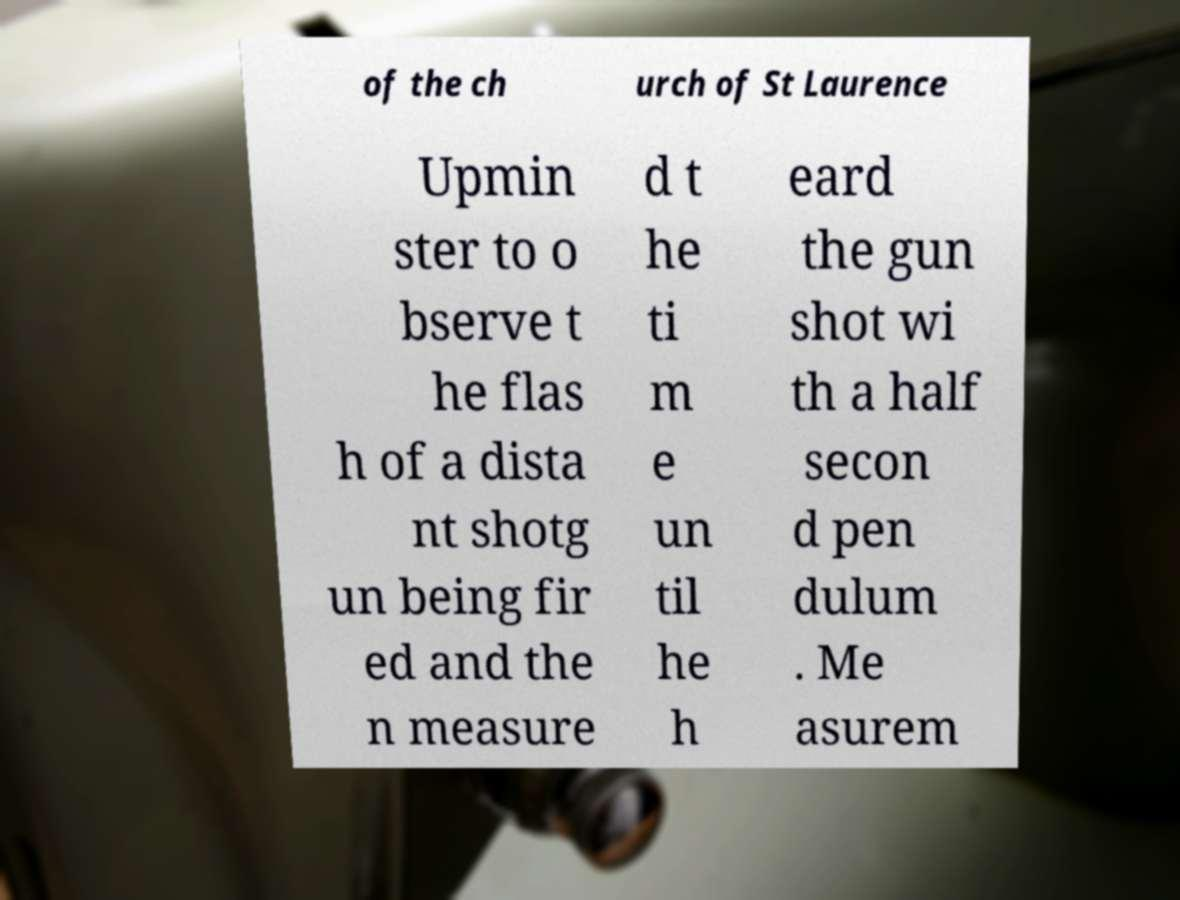What messages or text are displayed in this image? I need them in a readable, typed format. of the ch urch of St Laurence Upmin ster to o bserve t he flas h of a dista nt shotg un being fir ed and the n measure d t he ti m e un til he h eard the gun shot wi th a half secon d pen dulum . Me asurem 